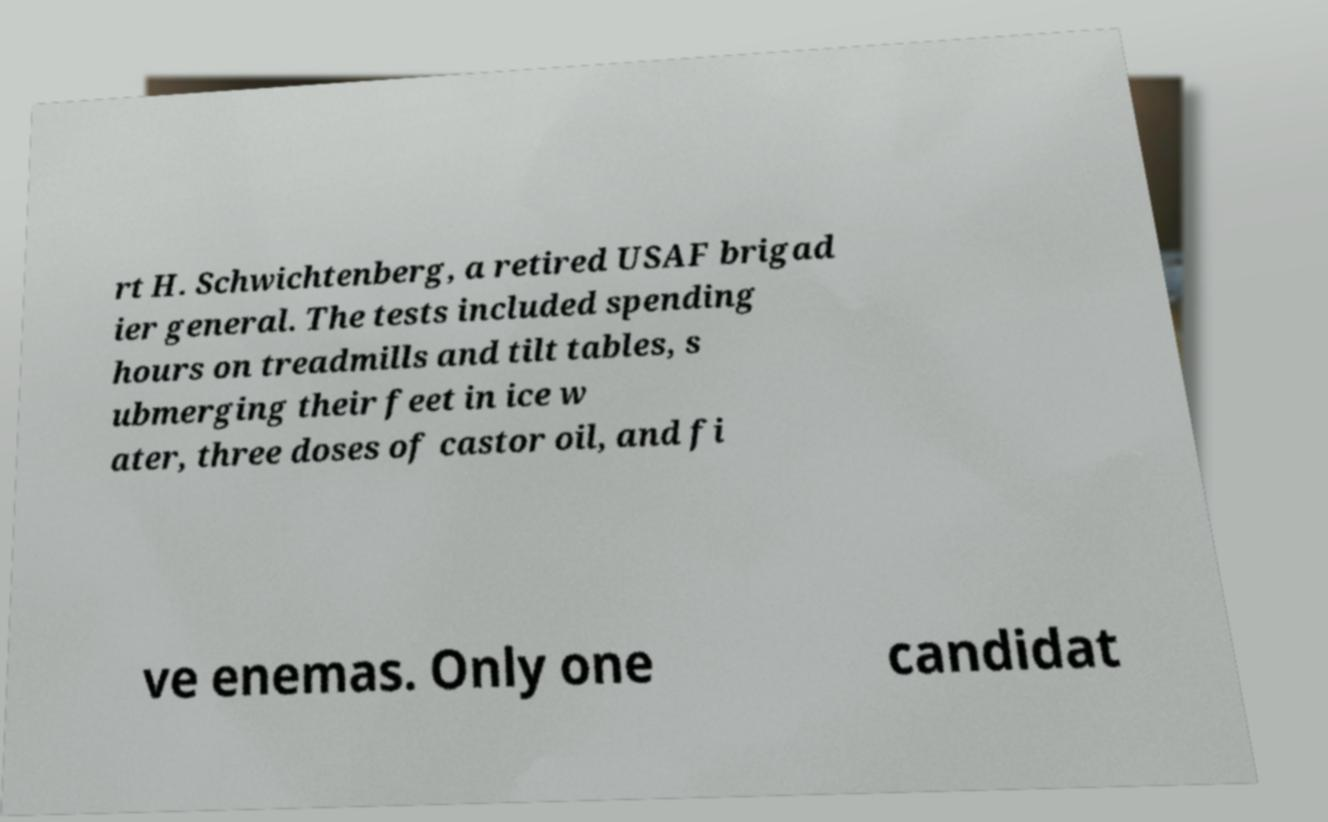Please read and relay the text visible in this image. What does it say? rt H. Schwichtenberg, a retired USAF brigad ier general. The tests included spending hours on treadmills and tilt tables, s ubmerging their feet in ice w ater, three doses of castor oil, and fi ve enemas. Only one candidat 